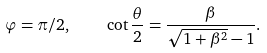<formula> <loc_0><loc_0><loc_500><loc_500>\varphi = \pi / 2 , \quad \cot \frac { \theta } { 2 } = \frac { \beta } { \sqrt { 1 + \beta ^ { 2 } } - 1 } .</formula> 